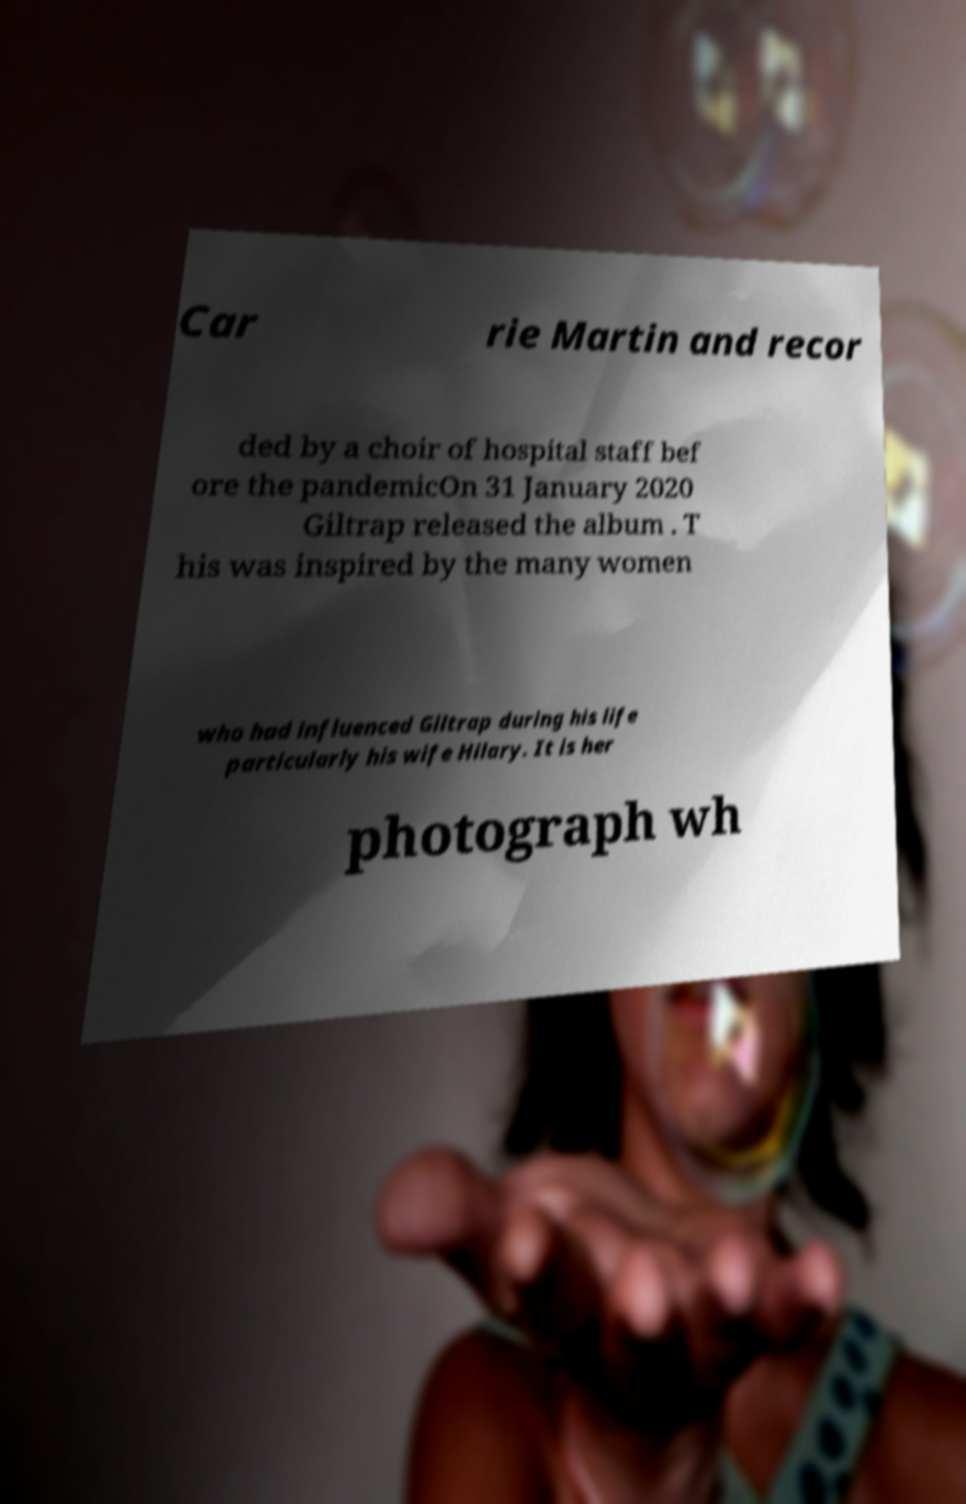Could you assist in decoding the text presented in this image and type it out clearly? Car rie Martin and recor ded by a choir of hospital staff bef ore the pandemicOn 31 January 2020 Giltrap released the album . T his was inspired by the many women who had influenced Giltrap during his life particularly his wife Hilary. It is her photograph wh 